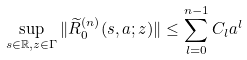<formula> <loc_0><loc_0><loc_500><loc_500>\sup _ { s \in \mathbb { R } , z \in \Gamma } \| \widetilde { R } _ { 0 } ^ { ( n ) } ( s , a ; z ) \| \leq \sum _ { l = 0 } ^ { n - 1 } C _ { l } a ^ { l }</formula> 